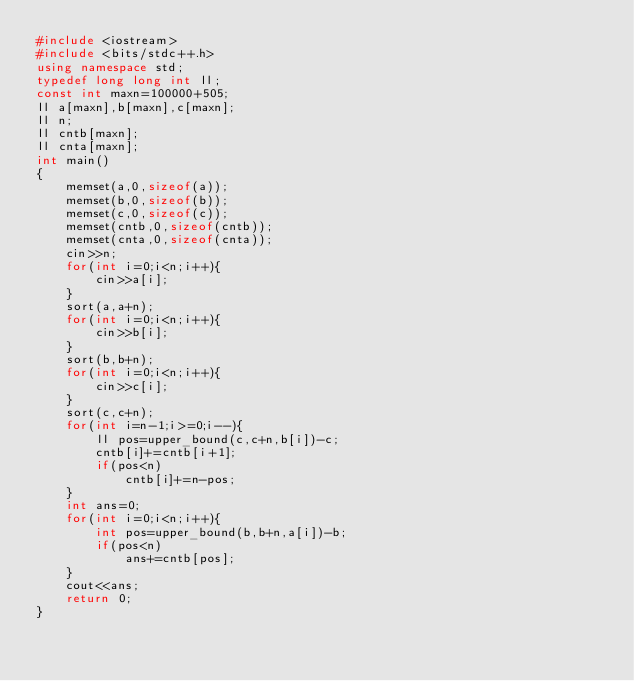<code> <loc_0><loc_0><loc_500><loc_500><_C++_>#include <iostream>
#include <bits/stdc++.h>
using namespace std;
typedef long long int ll;
const int maxn=100000+505;
ll a[maxn],b[maxn],c[maxn];
ll n;
ll cntb[maxn];
ll cnta[maxn];
int main()
{
    memset(a,0,sizeof(a));
    memset(b,0,sizeof(b));
    memset(c,0,sizeof(c));
    memset(cntb,0,sizeof(cntb));
    memset(cnta,0,sizeof(cnta));
    cin>>n;
    for(int i=0;i<n;i++){
        cin>>a[i];
    }
    sort(a,a+n);
    for(int i=0;i<n;i++){
        cin>>b[i];
    }
    sort(b,b+n);
    for(int i=0;i<n;i++){
        cin>>c[i];
    }
    sort(c,c+n);
    for(int i=n-1;i>=0;i--){
        ll pos=upper_bound(c,c+n,b[i])-c;
        cntb[i]+=cntb[i+1];
        if(pos<n)
            cntb[i]+=n-pos;
    }
    int ans=0;
    for(int i=0;i<n;i++){
        int pos=upper_bound(b,b+n,a[i])-b;
        if(pos<n)
            ans+=cntb[pos];
    }
    cout<<ans;
    return 0;
}
</code> 